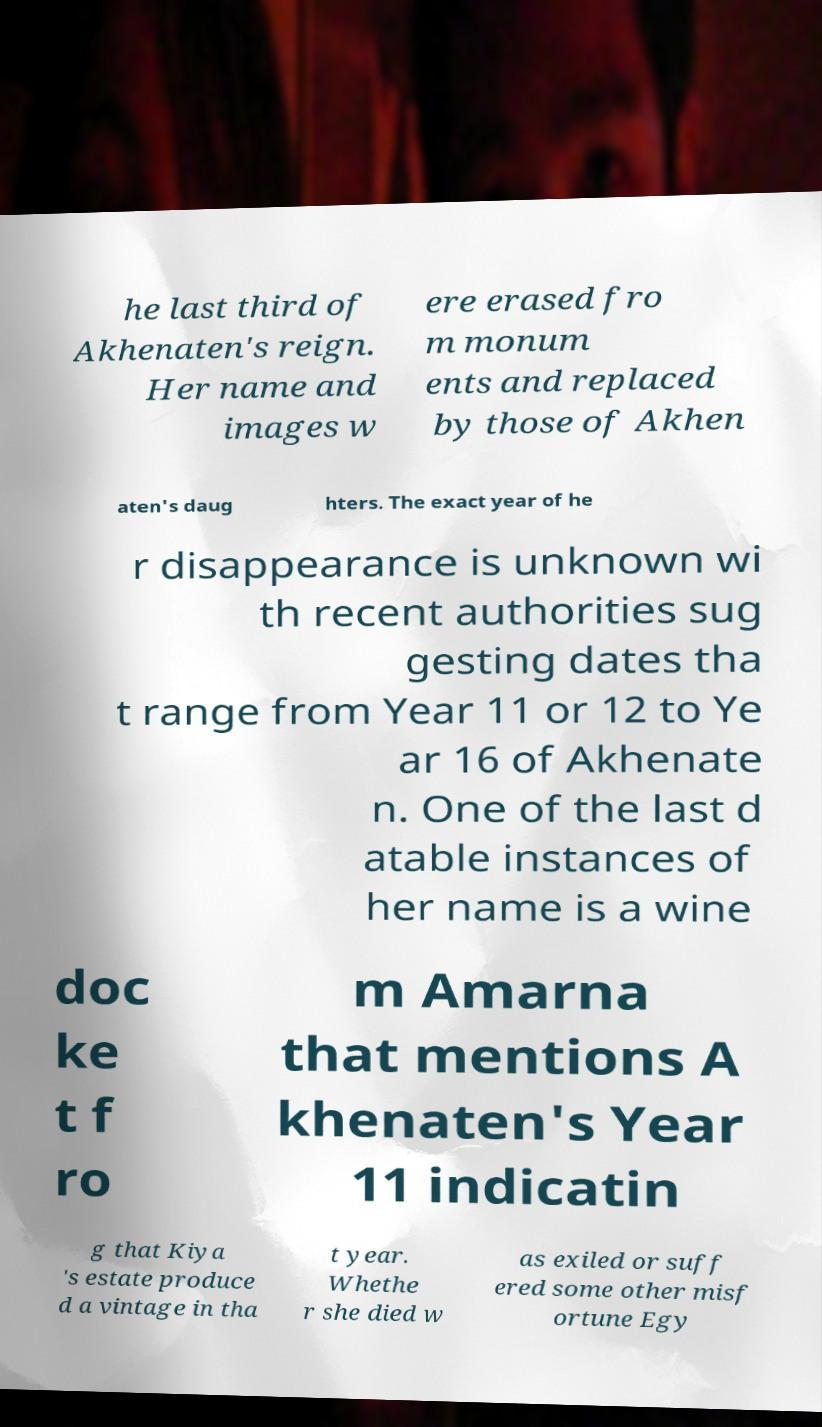Can you read and provide the text displayed in the image?This photo seems to have some interesting text. Can you extract and type it out for me? he last third of Akhenaten's reign. Her name and images w ere erased fro m monum ents and replaced by those of Akhen aten's daug hters. The exact year of he r disappearance is unknown wi th recent authorities sug gesting dates tha t range from Year 11 or 12 to Ye ar 16 of Akhenate n. One of the last d atable instances of her name is a wine doc ke t f ro m Amarna that mentions A khenaten's Year 11 indicatin g that Kiya 's estate produce d a vintage in tha t year. Whethe r she died w as exiled or suff ered some other misf ortune Egy 